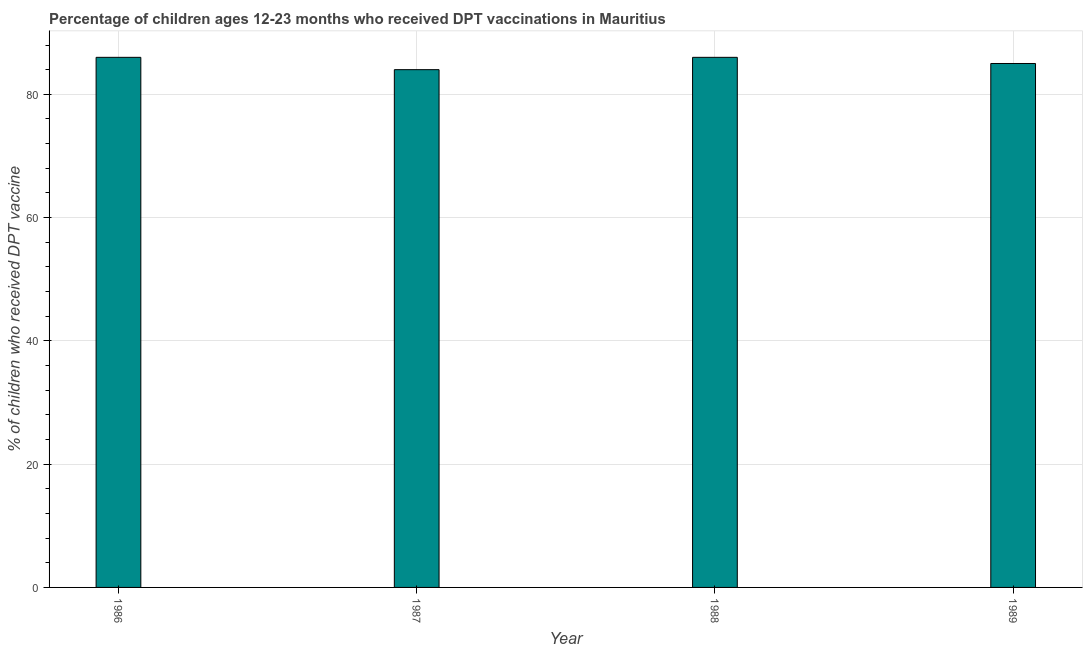Does the graph contain any zero values?
Provide a succinct answer. No. Does the graph contain grids?
Offer a terse response. Yes. What is the title of the graph?
Provide a short and direct response. Percentage of children ages 12-23 months who received DPT vaccinations in Mauritius. What is the label or title of the Y-axis?
Make the answer very short. % of children who received DPT vaccine. What is the sum of the percentage of children who received dpt vaccine?
Your answer should be compact. 341. What is the median percentage of children who received dpt vaccine?
Your answer should be very brief. 85.5. In how many years, is the percentage of children who received dpt vaccine greater than 40 %?
Make the answer very short. 4. Do a majority of the years between 1988 and 1989 (inclusive) have percentage of children who received dpt vaccine greater than 32 %?
Your answer should be compact. Yes. How many bars are there?
Offer a terse response. 4. How many years are there in the graph?
Keep it short and to the point. 4. What is the difference between two consecutive major ticks on the Y-axis?
Your answer should be very brief. 20. What is the % of children who received DPT vaccine of 1987?
Ensure brevity in your answer.  84. What is the % of children who received DPT vaccine in 1988?
Keep it short and to the point. 86. What is the difference between the % of children who received DPT vaccine in 1986 and 1987?
Your answer should be very brief. 2. What is the difference between the % of children who received DPT vaccine in 1987 and 1988?
Ensure brevity in your answer.  -2. What is the difference between the % of children who received DPT vaccine in 1987 and 1989?
Keep it short and to the point. -1. What is the ratio of the % of children who received DPT vaccine in 1986 to that in 1988?
Keep it short and to the point. 1. What is the ratio of the % of children who received DPT vaccine in 1987 to that in 1988?
Your response must be concise. 0.98. What is the ratio of the % of children who received DPT vaccine in 1987 to that in 1989?
Offer a very short reply. 0.99. What is the ratio of the % of children who received DPT vaccine in 1988 to that in 1989?
Provide a short and direct response. 1.01. 